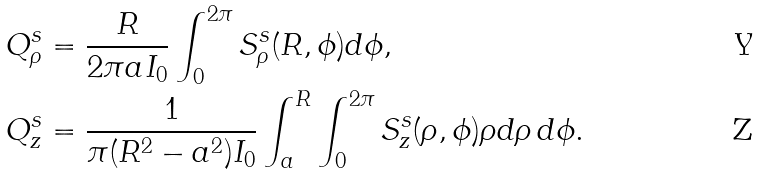<formula> <loc_0><loc_0><loc_500><loc_500>Q ^ { s } _ { \rho } & = \frac { R } { 2 \pi a I _ { 0 } } \int _ { 0 } ^ { 2 \pi } S ^ { s } _ { \rho } ( R , \phi ) d \phi , \\ Q ^ { s } _ { z } & = \frac { 1 } { \pi ( R ^ { 2 } - a ^ { 2 } ) I _ { 0 } } \int _ { a } ^ { R } \int _ { 0 } ^ { 2 \pi } S ^ { s } _ { z } ( \rho , \phi ) \rho d \rho \, d \phi .</formula> 